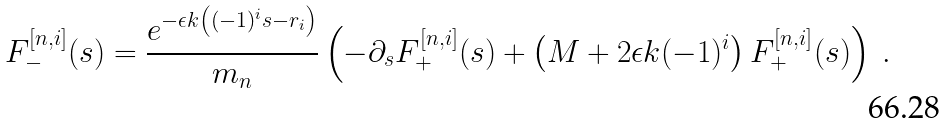<formula> <loc_0><loc_0><loc_500><loc_500>F _ { - } ^ { [ n , i ] } ( s ) = \frac { e ^ { - \epsilon k \left ( ( - 1 ) ^ { i } s - r _ { i } \right ) } } { m _ { n } } \left ( - \partial _ { s } F _ { + } ^ { [ n , i ] } ( s ) + \left ( M + 2 \epsilon k ( - 1 ) ^ { i } \right ) F _ { + } ^ { [ n , i ] } ( s ) \right ) \ .</formula> 